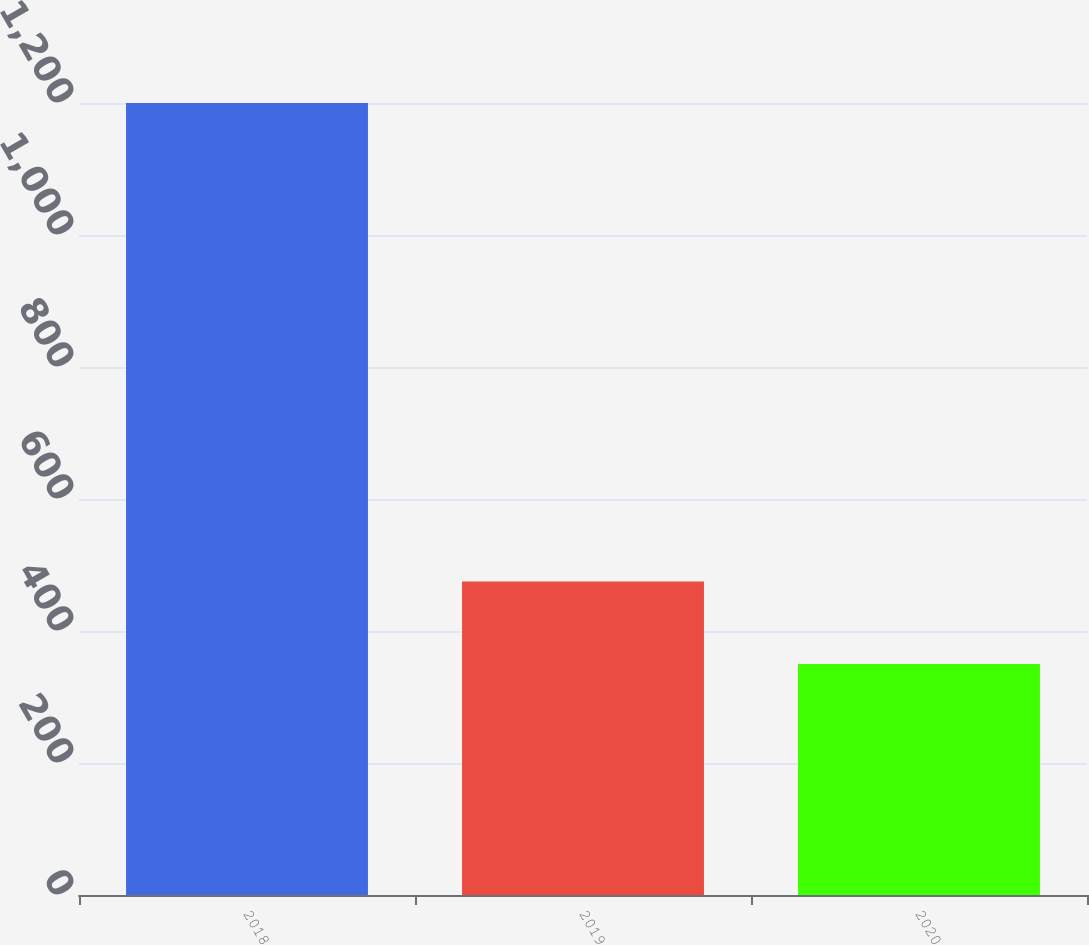Convert chart. <chart><loc_0><loc_0><loc_500><loc_500><bar_chart><fcel>2018<fcel>2019<fcel>2020<nl><fcel>1200<fcel>475<fcel>350<nl></chart> 